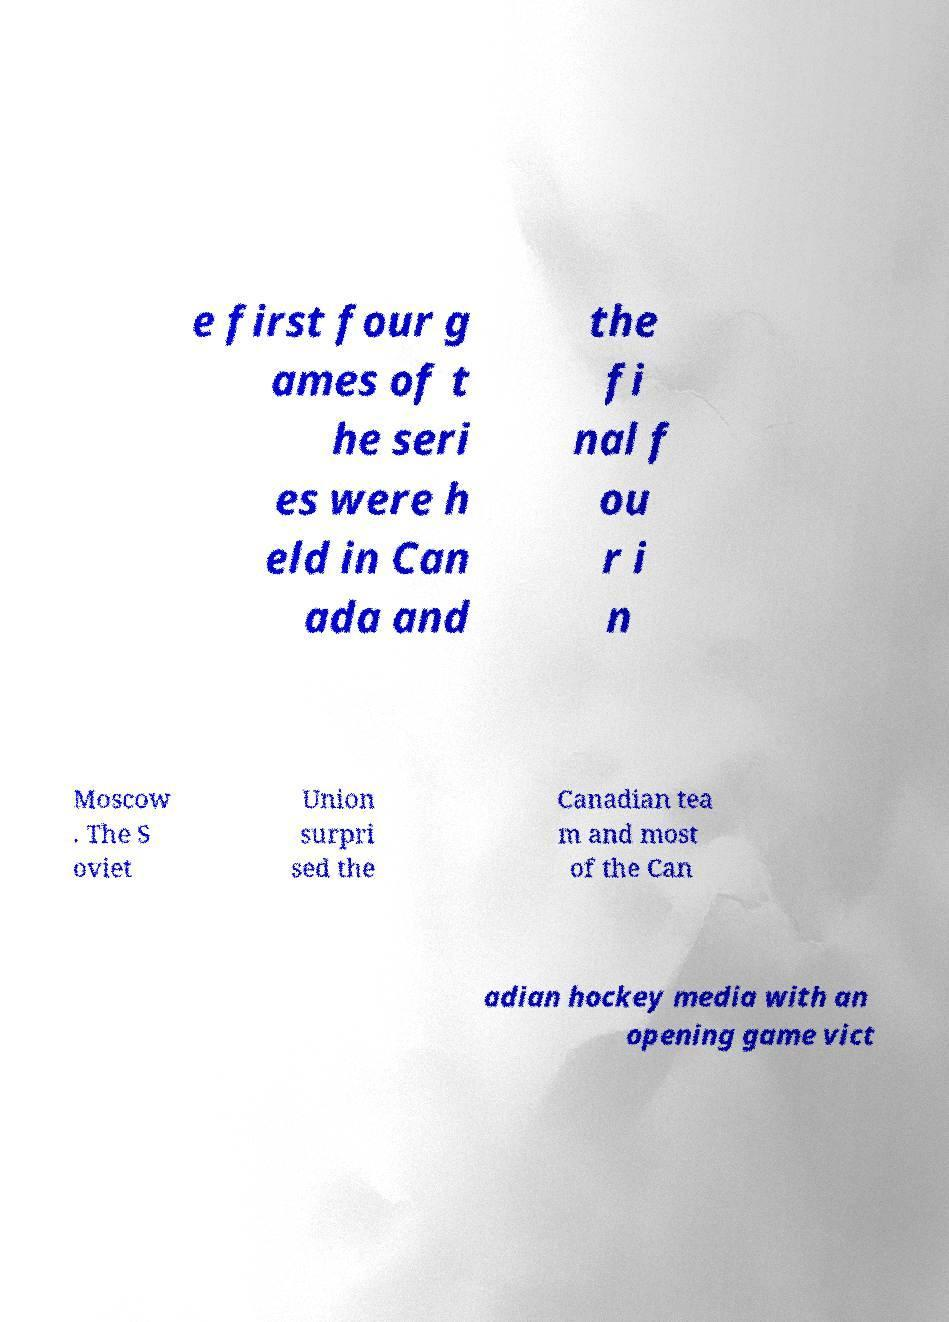There's text embedded in this image that I need extracted. Can you transcribe it verbatim? e first four g ames of t he seri es were h eld in Can ada and the fi nal f ou r i n Moscow . The S oviet Union surpri sed the Canadian tea m and most of the Can adian hockey media with an opening game vict 